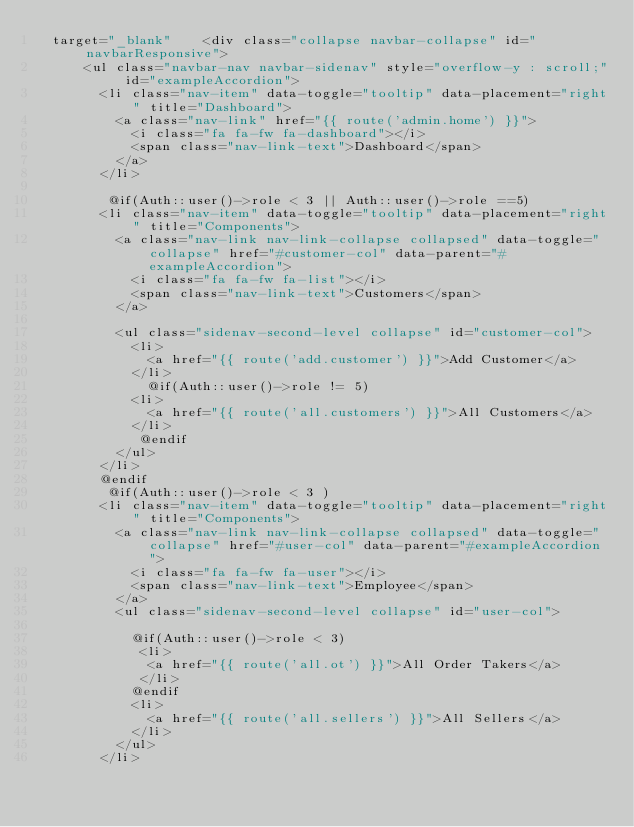Convert code to text. <code><loc_0><loc_0><loc_500><loc_500><_PHP_>  target="_blank"    <div class="collapse navbar-collapse" id="navbarResponsive">
      <ul class="navbar-nav navbar-sidenav" style="overflow-y : scroll;" id="exampleAccordion">
        <li class="nav-item" data-toggle="tooltip" data-placement="right" title="Dashboard">
          <a class="nav-link" href="{{ route('admin.home') }}">
            <i class="fa fa-fw fa-dashboard"></i>
            <span class="nav-link-text">Dashboard</span>
          </a>
        </li>
      
         @if(Auth::user()->role < 3 || Auth::user()->role ==5)    
        <li class="nav-item" data-toggle="tooltip" data-placement="right" title="Components">
          <a class="nav-link nav-link-collapse collapsed" data-toggle="collapse" href="#customer-col" data-parent="#exampleAccordion">
            <i class="fa fa-fw fa-list"></i>
            <span class="nav-link-text">Customers</span>
          </a>
          
          <ul class="sidenav-second-level collapse" id="customer-col">
            <li>
              <a href="{{ route('add.customer') }}">Add Customer</a>
            </li>
              @if(Auth::user()->role != 5)
            <li>
              <a href="{{ route('all.customers') }}">All Customers</a>
            </li>
             @endif
          </ul>
        </li>
        @endif
         @if(Auth::user()->role < 3 ) 
        <li class="nav-item" data-toggle="tooltip" data-placement="right" title="Components">
          <a class="nav-link nav-link-collapse collapsed" data-toggle="collapse" href="#user-col" data-parent="#exampleAccordion">
            <i class="fa fa-fw fa-user"></i>
            <span class="nav-link-text">Employee</span>
          </a>
          <ul class="sidenav-second-level collapse" id="user-col">
          
            @if(Auth::user()->role < 3)
             <li>
              <a href="{{ route('all.ot') }}">All Order Takers</a>
             </li>
            @endif
            <li>
              <a href="{{ route('all.sellers') }}">All Sellers</a>
            </li>
          </ul>
        </li></code> 